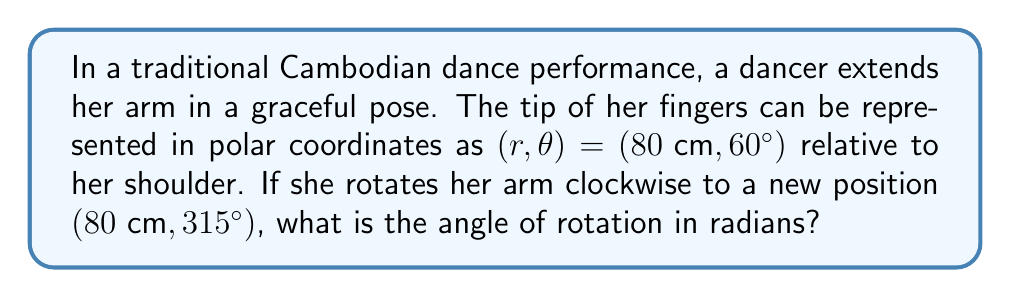Show me your answer to this math problem. To solve this problem, we need to follow these steps:

1) First, let's identify the initial and final angles in the polar coordinate system:
   Initial angle: $\theta_1 = 60°$
   Final angle: $\theta_2 = 315°$

2) To find the angle of rotation, we need to calculate the difference between these angles:
   $\Delta \theta = \theta_1 - \theta_2$

3) However, we need to be careful here. The rotation is clockwise, which means we're moving in the negative direction in the polar coordinate system. Also, we've crossed the positive x-axis (0°), so we need to add a full rotation (360°) to get the correct result:

   $\Delta \theta = (60° + 360°) - 315° = 420° - 315° = 105°$

4) Now we have the angle in degrees, but the question asks for the answer in radians. To convert from degrees to radians, we use the formula:

   $\theta_{\text{radians}} = \theta_{\text{degrees}} \cdot \frac{\pi}{180°}$

5) Let's apply this conversion:

   $105° \cdot \frac{\pi}{180°} = \frac{7\pi}{12} \approx 1.8326 \text{ radians}$

Therefore, the angle of rotation is $\frac{7\pi}{12}$ radians.
Answer: $\frac{7\pi}{12}$ radians 